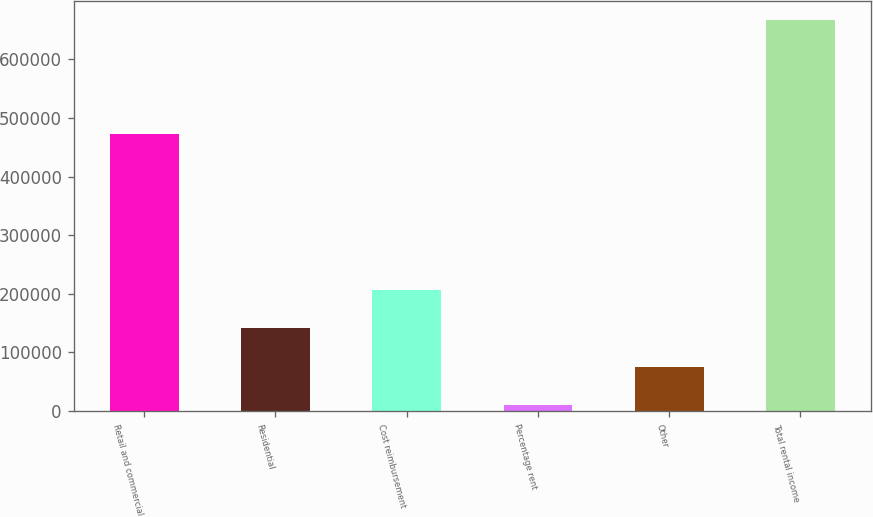Convert chart to OTSL. <chart><loc_0><loc_0><loc_500><loc_500><bar_chart><fcel>Retail and commercial<fcel>Residential<fcel>Cost reimbursement<fcel>Percentage rent<fcel>Other<fcel>Total rental income<nl><fcel>472602<fcel>141400<fcel>207015<fcel>10169<fcel>75784.3<fcel>666322<nl></chart> 